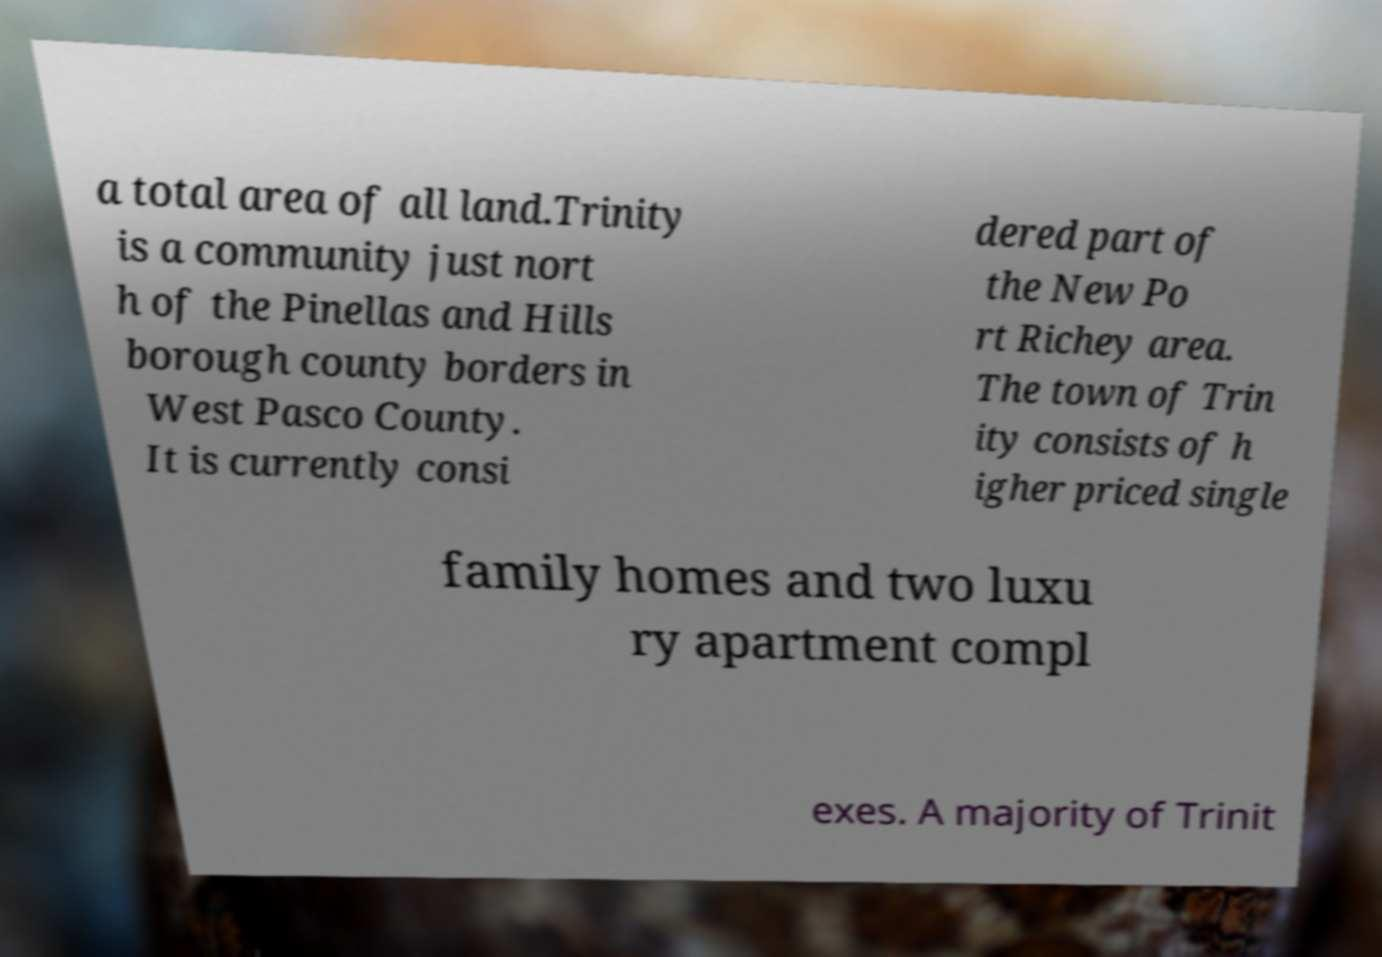Can you accurately transcribe the text from the provided image for me? a total area of all land.Trinity is a community just nort h of the Pinellas and Hills borough county borders in West Pasco County. It is currently consi dered part of the New Po rt Richey area. The town of Trin ity consists of h igher priced single family homes and two luxu ry apartment compl exes. A majority of Trinit 